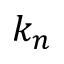Convert formula to latex. <formula><loc_0><loc_0><loc_500><loc_500>k _ { n }</formula> 